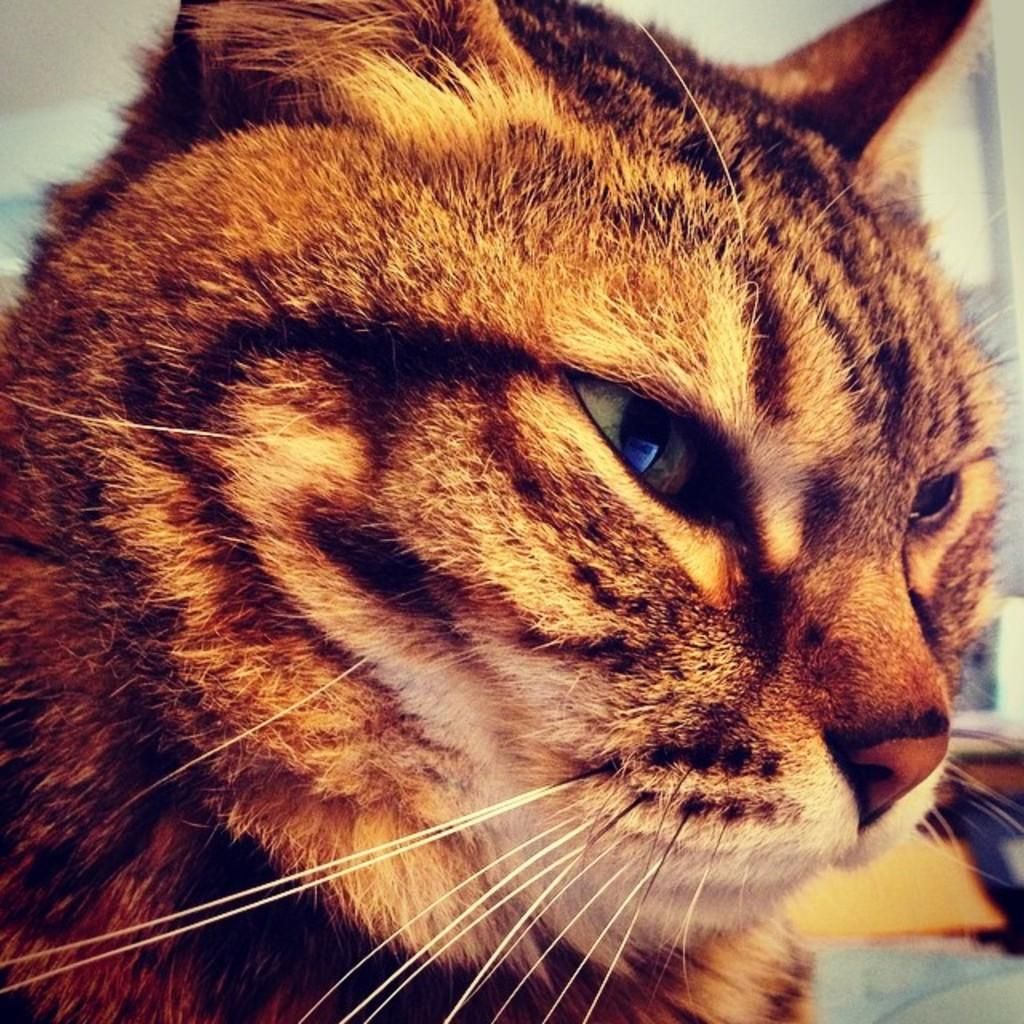What type of animal is in the image? There is a cat in the image. Can you describe the background of the image? The background of the image is blurred. What type of zephyr can be seen in the image? There is no zephyr present in the image; it features a cat and a blurred background. Is there a volcano visible in the image? No, there is no volcano present in the image. 